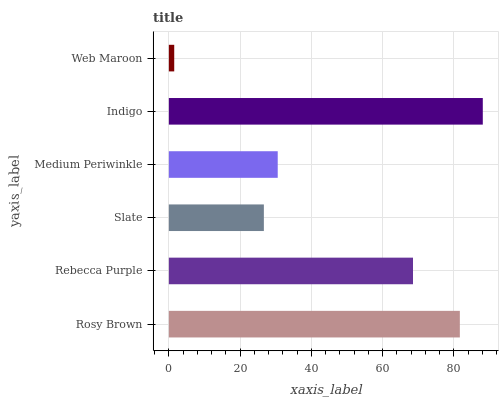Is Web Maroon the minimum?
Answer yes or no. Yes. Is Indigo the maximum?
Answer yes or no. Yes. Is Rebecca Purple the minimum?
Answer yes or no. No. Is Rebecca Purple the maximum?
Answer yes or no. No. Is Rosy Brown greater than Rebecca Purple?
Answer yes or no. Yes. Is Rebecca Purple less than Rosy Brown?
Answer yes or no. Yes. Is Rebecca Purple greater than Rosy Brown?
Answer yes or no. No. Is Rosy Brown less than Rebecca Purple?
Answer yes or no. No. Is Rebecca Purple the high median?
Answer yes or no. Yes. Is Medium Periwinkle the low median?
Answer yes or no. Yes. Is Indigo the high median?
Answer yes or no. No. Is Rosy Brown the low median?
Answer yes or no. No. 